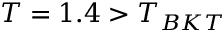<formula> <loc_0><loc_0><loc_500><loc_500>T = 1 . 4 > T _ { B K T }</formula> 